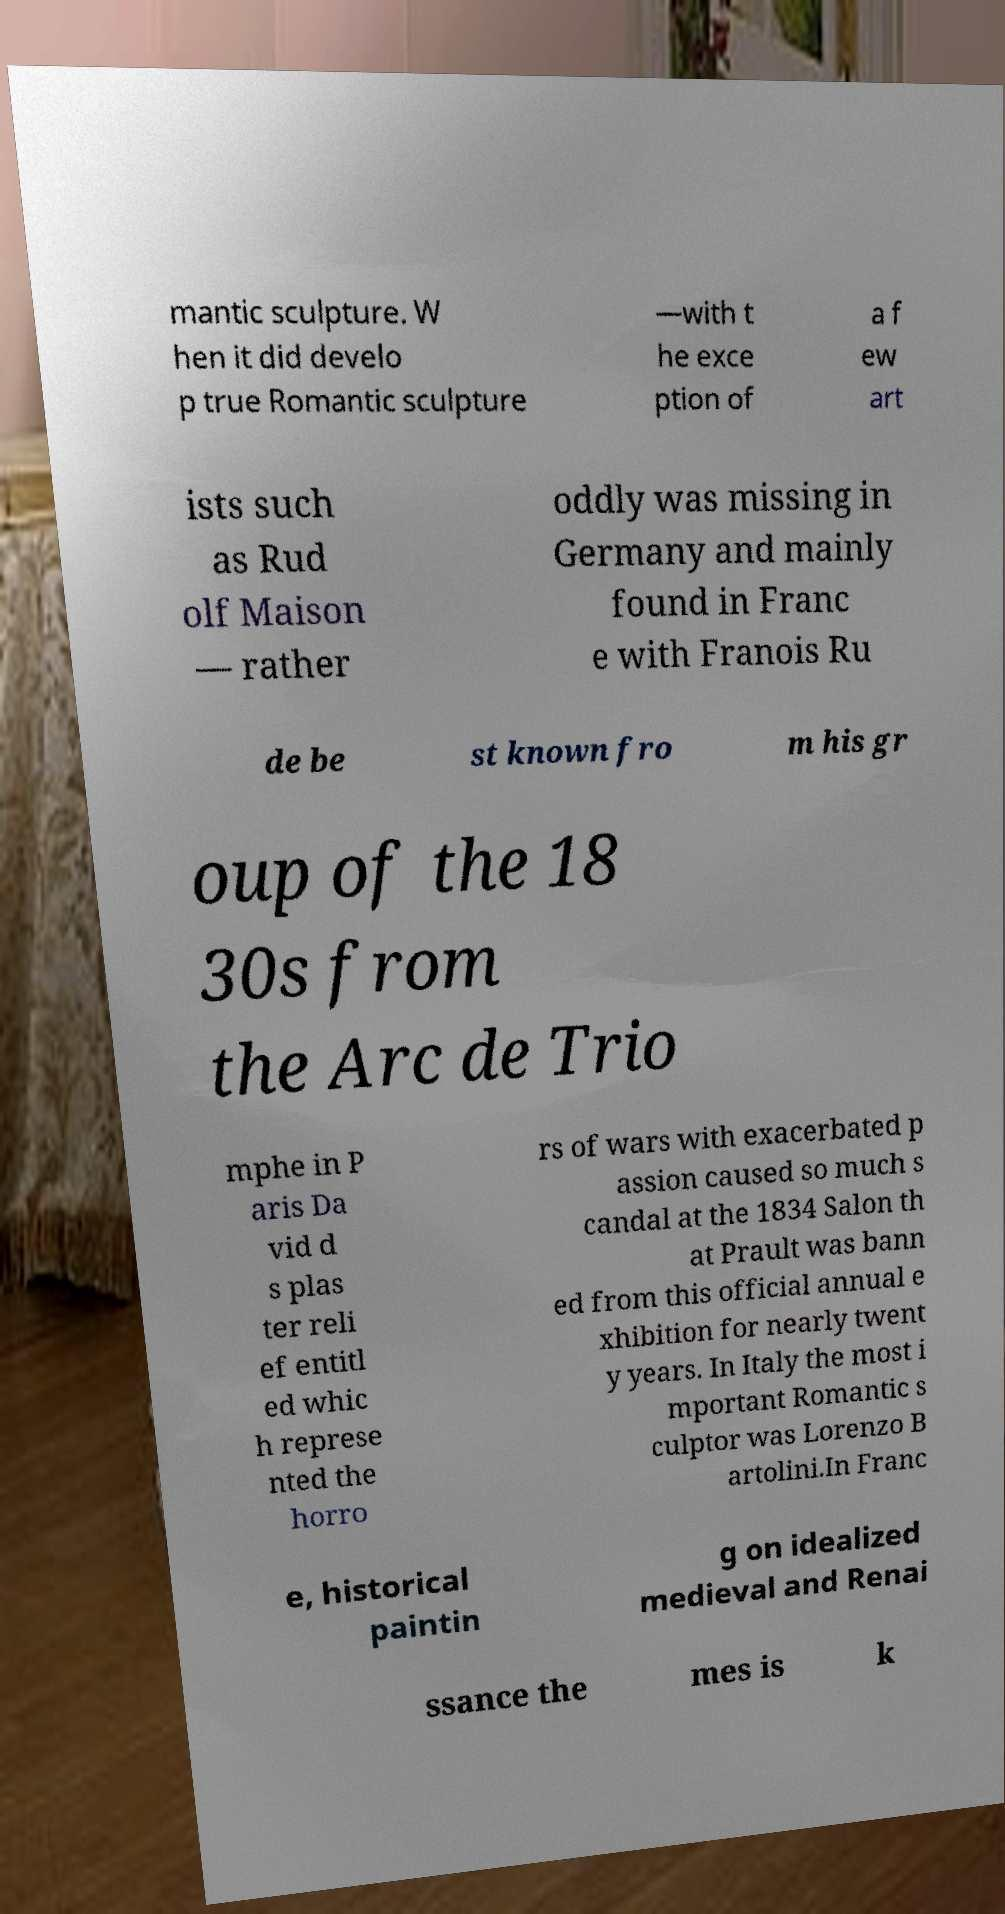Please identify and transcribe the text found in this image. mantic sculpture. W hen it did develo p true Romantic sculpture —with t he exce ption of a f ew art ists such as Rud olf Maison — rather oddly was missing in Germany and mainly found in Franc e with Franois Ru de be st known fro m his gr oup of the 18 30s from the Arc de Trio mphe in P aris Da vid d s plas ter reli ef entitl ed whic h represe nted the horro rs of wars with exacerbated p assion caused so much s candal at the 1834 Salon th at Prault was bann ed from this official annual e xhibition for nearly twent y years. In Italy the most i mportant Romantic s culptor was Lorenzo B artolini.In Franc e, historical paintin g on idealized medieval and Renai ssance the mes is k 